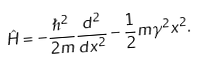<formula> <loc_0><loc_0><loc_500><loc_500>\hat { H } = - \frac { \hslash ^ { 2 } } { 2 m } \frac { d ^ { 2 } } { d x ^ { 2 } } - \frac { 1 } { 2 } m \gamma ^ { 2 } x ^ { 2 } .</formula> 